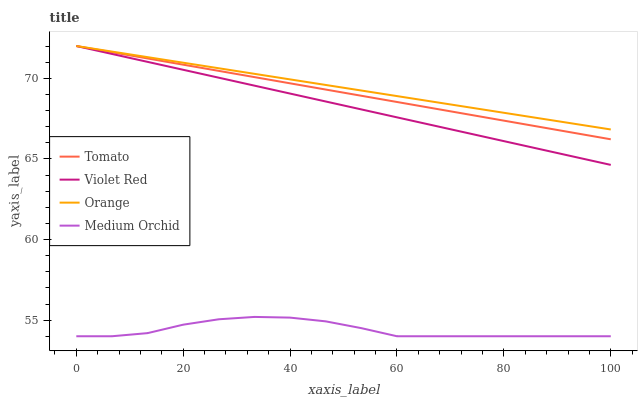Does Medium Orchid have the minimum area under the curve?
Answer yes or no. Yes. Does Orange have the maximum area under the curve?
Answer yes or no. Yes. Does Violet Red have the minimum area under the curve?
Answer yes or no. No. Does Violet Red have the maximum area under the curve?
Answer yes or no. No. Is Violet Red the smoothest?
Answer yes or no. Yes. Is Medium Orchid the roughest?
Answer yes or no. Yes. Is Orange the smoothest?
Answer yes or no. No. Is Orange the roughest?
Answer yes or no. No. Does Violet Red have the lowest value?
Answer yes or no. No. Does Violet Red have the highest value?
Answer yes or no. Yes. Does Medium Orchid have the highest value?
Answer yes or no. No. Is Medium Orchid less than Orange?
Answer yes or no. Yes. Is Violet Red greater than Medium Orchid?
Answer yes or no. Yes. Does Violet Red intersect Orange?
Answer yes or no. Yes. Is Violet Red less than Orange?
Answer yes or no. No. Is Violet Red greater than Orange?
Answer yes or no. No. Does Medium Orchid intersect Orange?
Answer yes or no. No. 